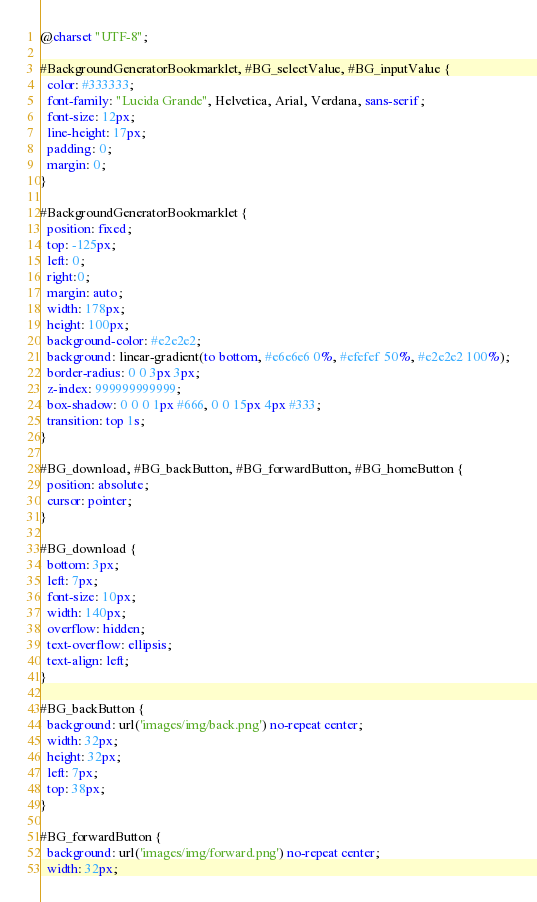<code> <loc_0><loc_0><loc_500><loc_500><_CSS_>@charset "UTF-8";

#BackgroundGeneratorBookmarklet, #BG_selectValue, #BG_inputValue {
  color: #333333;
  font-family: "Lucida Grande", Helvetica, Arial, Verdana, sans-serif;
  font-size: 12px;
  line-height: 17px;
  padding: 0;
  margin: 0;
}

#BackgroundGeneratorBookmarklet {
  position: fixed;
  top: -125px;
  left: 0;
  right:0;
  margin: auto;
  width: 178px;
  height: 100px;
  background-color: #e2e2e2;
  background: linear-gradient(to bottom, #e6e6e6 0%, #efefef 50%, #e2e2e2 100%);
  border-radius: 0 0 3px 3px;
  z-index: 999999999999;
  box-shadow: 0 0 0 1px #666, 0 0 15px 4px #333;
  transition: top 1s;
}

#BG_download, #BG_backButton, #BG_forwardButton, #BG_homeButton {
  position: absolute;
  cursor: pointer;
}

#BG_download {
  bottom: 3px;
  left: 7px;
  font-size: 10px;
  width: 140px;
  overflow: hidden;
  text-overflow: ellipsis;
  text-align: left;
}

#BG_backButton {
  background: url('images/img/back.png') no-repeat center;
  width: 32px;
  height: 32px;
  left: 7px;
  top: 38px;
}

#BG_forwardButton {
  background: url('images/img/forward.png') no-repeat center;
  width: 32px;</code> 